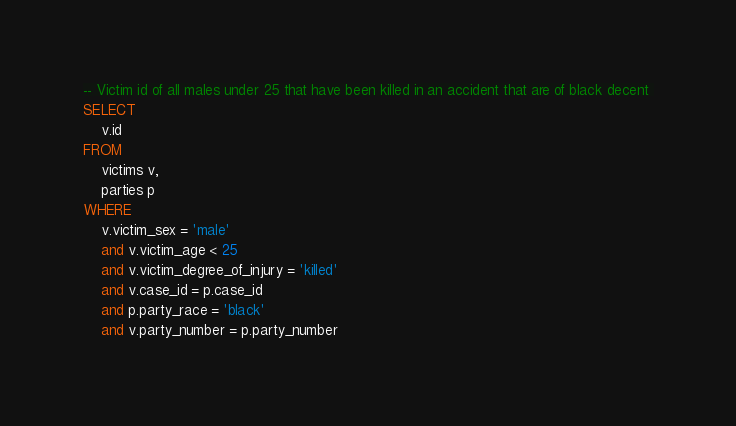<code> <loc_0><loc_0><loc_500><loc_500><_SQL_>-- Victim id of all males under 25 that have been killed in an accident that are of black decent 
SELECT
    v.id
FROM
    victims v,
    parties p
WHERE
    v.victim_sex = 'male'
    and v.victim_age < 25
    and v.victim_degree_of_injury = 'killed'
    and v.case_id = p.case_id
    and p.party_race = 'black'
    and v.party_number = p.party_number</code> 